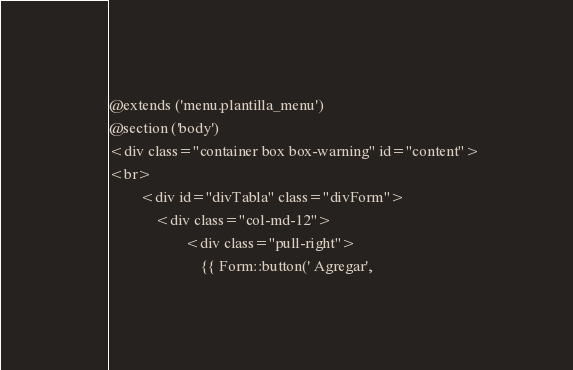<code> <loc_0><loc_0><loc_500><loc_500><_PHP_>@extends ('menu.plantilla_menu')
@section ('body')
<div class="container box box-warning" id="content">
<br>
        <div id="divTabla" class="divForm">
            <div class="col-md-12">
                    <div class="pull-right">
                        {{ Form::button(' Agregar',</code> 